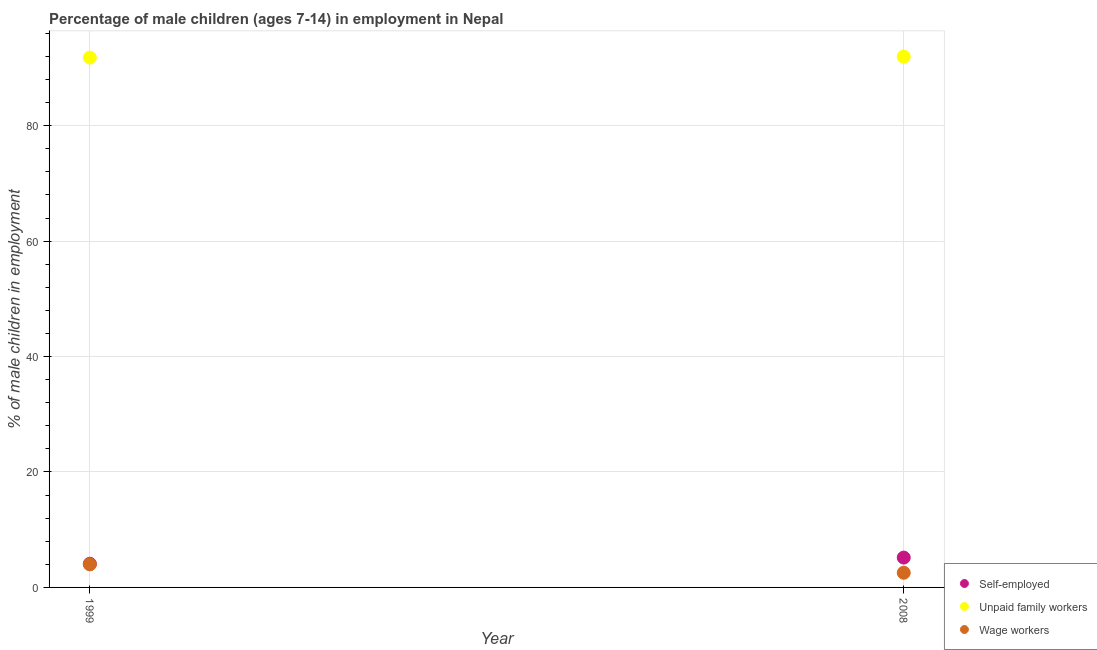Is the number of dotlines equal to the number of legend labels?
Ensure brevity in your answer.  Yes. What is the percentage of children employed as wage workers in 2008?
Ensure brevity in your answer.  2.54. Across all years, what is the maximum percentage of self employed children?
Provide a short and direct response. 5.17. Across all years, what is the minimum percentage of children employed as wage workers?
Provide a succinct answer. 2.54. What is the total percentage of children employed as wage workers in the graph?
Offer a very short reply. 6.54. What is the difference between the percentage of self employed children in 1999 and that in 2008?
Keep it short and to the point. -1.07. What is the difference between the percentage of children employed as wage workers in 1999 and the percentage of children employed as unpaid family workers in 2008?
Ensure brevity in your answer.  -87.97. What is the average percentage of children employed as unpaid family workers per year?
Provide a succinct answer. 91.88. In the year 1999, what is the difference between the percentage of children employed as wage workers and percentage of self employed children?
Provide a succinct answer. -0.1. What is the ratio of the percentage of children employed as unpaid family workers in 1999 to that in 2008?
Ensure brevity in your answer.  1. Is the percentage of self employed children in 1999 less than that in 2008?
Provide a short and direct response. Yes. How many dotlines are there?
Your answer should be compact. 3. How many years are there in the graph?
Give a very brief answer. 2. What is the difference between two consecutive major ticks on the Y-axis?
Your answer should be very brief. 20. Are the values on the major ticks of Y-axis written in scientific E-notation?
Keep it short and to the point. No. Does the graph contain any zero values?
Your response must be concise. No. Does the graph contain grids?
Your answer should be compact. Yes. How many legend labels are there?
Provide a short and direct response. 3. What is the title of the graph?
Offer a terse response. Percentage of male children (ages 7-14) in employment in Nepal. What is the label or title of the X-axis?
Your response must be concise. Year. What is the label or title of the Y-axis?
Your response must be concise. % of male children in employment. What is the % of male children in employment of Self-employed in 1999?
Give a very brief answer. 4.1. What is the % of male children in employment in Unpaid family workers in 1999?
Keep it short and to the point. 91.8. What is the % of male children in employment in Self-employed in 2008?
Offer a terse response. 5.17. What is the % of male children in employment of Unpaid family workers in 2008?
Your response must be concise. 91.97. What is the % of male children in employment of Wage workers in 2008?
Offer a very short reply. 2.54. Across all years, what is the maximum % of male children in employment of Self-employed?
Your answer should be compact. 5.17. Across all years, what is the maximum % of male children in employment in Unpaid family workers?
Offer a terse response. 91.97. Across all years, what is the minimum % of male children in employment in Self-employed?
Your answer should be compact. 4.1. Across all years, what is the minimum % of male children in employment of Unpaid family workers?
Provide a succinct answer. 91.8. Across all years, what is the minimum % of male children in employment in Wage workers?
Offer a terse response. 2.54. What is the total % of male children in employment in Self-employed in the graph?
Make the answer very short. 9.27. What is the total % of male children in employment in Unpaid family workers in the graph?
Your answer should be compact. 183.77. What is the total % of male children in employment in Wage workers in the graph?
Make the answer very short. 6.54. What is the difference between the % of male children in employment of Self-employed in 1999 and that in 2008?
Give a very brief answer. -1.07. What is the difference between the % of male children in employment in Unpaid family workers in 1999 and that in 2008?
Provide a short and direct response. -0.17. What is the difference between the % of male children in employment of Wage workers in 1999 and that in 2008?
Your answer should be compact. 1.46. What is the difference between the % of male children in employment in Self-employed in 1999 and the % of male children in employment in Unpaid family workers in 2008?
Offer a terse response. -87.87. What is the difference between the % of male children in employment in Self-employed in 1999 and the % of male children in employment in Wage workers in 2008?
Offer a very short reply. 1.56. What is the difference between the % of male children in employment of Unpaid family workers in 1999 and the % of male children in employment of Wage workers in 2008?
Give a very brief answer. 89.26. What is the average % of male children in employment in Self-employed per year?
Make the answer very short. 4.63. What is the average % of male children in employment of Unpaid family workers per year?
Keep it short and to the point. 91.89. What is the average % of male children in employment in Wage workers per year?
Offer a terse response. 3.27. In the year 1999, what is the difference between the % of male children in employment of Self-employed and % of male children in employment of Unpaid family workers?
Provide a succinct answer. -87.7. In the year 1999, what is the difference between the % of male children in employment of Self-employed and % of male children in employment of Wage workers?
Offer a terse response. 0.1. In the year 1999, what is the difference between the % of male children in employment in Unpaid family workers and % of male children in employment in Wage workers?
Offer a very short reply. 87.8. In the year 2008, what is the difference between the % of male children in employment in Self-employed and % of male children in employment in Unpaid family workers?
Make the answer very short. -86.8. In the year 2008, what is the difference between the % of male children in employment in Self-employed and % of male children in employment in Wage workers?
Provide a succinct answer. 2.63. In the year 2008, what is the difference between the % of male children in employment in Unpaid family workers and % of male children in employment in Wage workers?
Your answer should be compact. 89.43. What is the ratio of the % of male children in employment in Self-employed in 1999 to that in 2008?
Offer a very short reply. 0.79. What is the ratio of the % of male children in employment in Unpaid family workers in 1999 to that in 2008?
Make the answer very short. 1. What is the ratio of the % of male children in employment in Wage workers in 1999 to that in 2008?
Give a very brief answer. 1.57. What is the difference between the highest and the second highest % of male children in employment in Self-employed?
Your response must be concise. 1.07. What is the difference between the highest and the second highest % of male children in employment of Unpaid family workers?
Make the answer very short. 0.17. What is the difference between the highest and the second highest % of male children in employment in Wage workers?
Your answer should be compact. 1.46. What is the difference between the highest and the lowest % of male children in employment in Self-employed?
Provide a succinct answer. 1.07. What is the difference between the highest and the lowest % of male children in employment of Unpaid family workers?
Give a very brief answer. 0.17. What is the difference between the highest and the lowest % of male children in employment in Wage workers?
Your response must be concise. 1.46. 